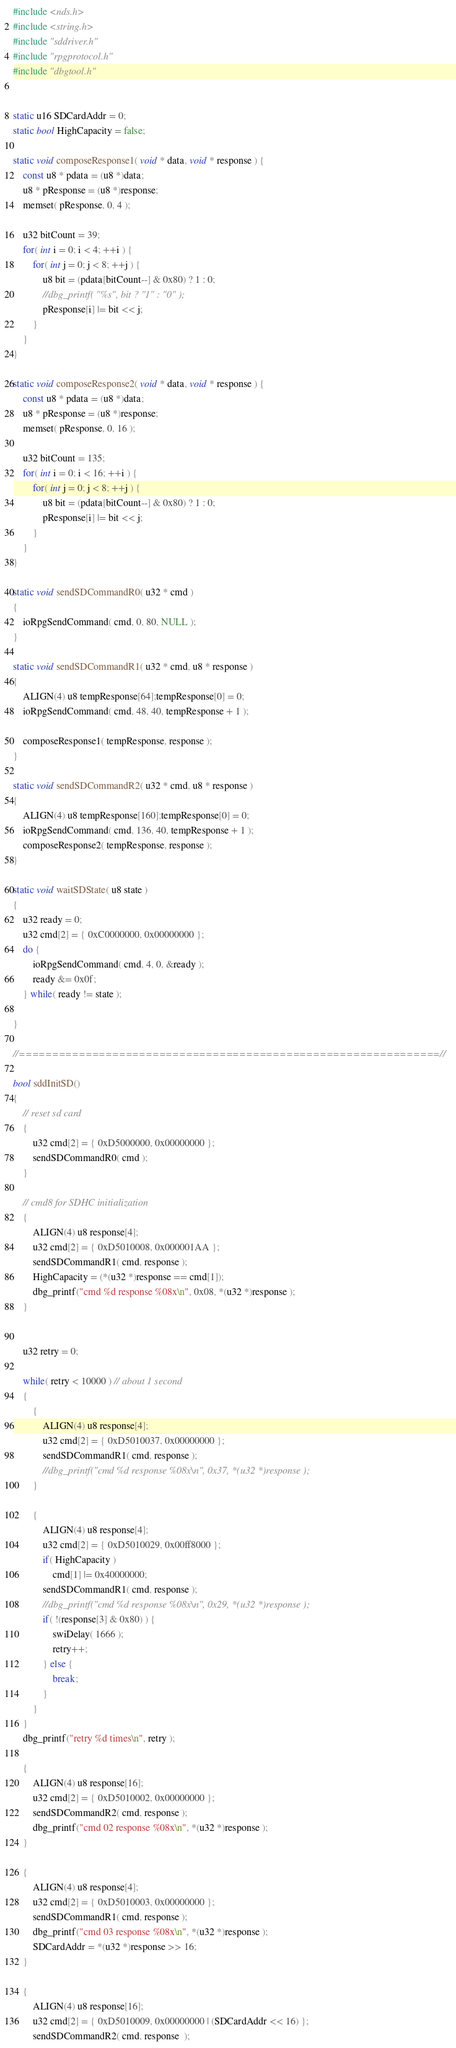Convert code to text. <code><loc_0><loc_0><loc_500><loc_500><_C++_>#include <nds.h>
#include <string.h>
#include "sddriver.h"
#include "rpgprotocol.h"
#include "dbgtool.h"


static u16 SDCardAddr = 0;
static bool HighCapacity = false;

static void composeResponse1( void * data, void * response ) {
	const u8 * pdata = (u8 *)data;
	u8 * pResponse = (u8 *)response;
	memset( pResponse, 0, 4 );

	u32 bitCount = 39;
	for( int i = 0; i < 4; ++i ) {
		for( int j = 0; j < 8; ++j ) {
			u8 bit = (pdata[bitCount--] & 0x80) ? 1 : 0;
			//dbg_printf( "%s", bit ? "1" : "0" );
			pResponse[i] |= bit << j;
		}
	}
}

static void composeResponse2( void * data, void * response ) {
	const u8 * pdata = (u8 *)data;
	u8 * pResponse = (u8 *)response;
	memset( pResponse, 0, 16 );

	u32 bitCount = 135;
	for( int i = 0; i < 16; ++i ) {
		for( int j = 0; j < 8; ++j ) {
			u8 bit = (pdata[bitCount--] & 0x80) ? 1 : 0;
			pResponse[i] |= bit << j;
		}
	}
}

static void sendSDCommandR0( u32 * cmd )
{
	ioRpgSendCommand( cmd, 0, 80, NULL );
}

static void sendSDCommandR1( u32 * cmd, u8 * response )
{
	ALIGN(4) u8 tempResponse[64];tempResponse[0] = 0;
	ioRpgSendCommand( cmd, 48, 40, tempResponse + 1 );

	composeResponse1( tempResponse, response );
}

static void sendSDCommandR2( u32 * cmd, u8 * response )
{
	ALIGN(4) u8 tempResponse[160];tempResponse[0] = 0;
	ioRpgSendCommand( cmd, 136, 40, tempResponse + 1 );
	composeResponse2( tempResponse, response );
}

static void waitSDState( u8 state )
{
	u32 ready = 0;
	u32 cmd[2] = { 0xC0000000, 0x00000000 };
	do {
		ioRpgSendCommand( cmd, 4, 0, &ready );
		ready &= 0x0f;
	} while( ready != state );

}

//===============================================================//

bool sddInitSD()
{
	// reset sd card
	{
		u32 cmd[2] = { 0xD5000000, 0x00000000 };
		sendSDCommandR0( cmd );
	}

	// cmd8 for SDHC initialization
	{
		ALIGN(4) u8 response[4];
		u32 cmd[2] = { 0xD5010008, 0x000001AA };
		sendSDCommandR1( cmd, response );
		HighCapacity = (*(u32 *)response == cmd[1]);
		dbg_printf("cmd %d response %08x\n", 0x08, *(u32 *)response );
	}


	u32 retry = 0;

	while( retry < 10000 ) // about 1 second
	{
		{
			ALIGN(4) u8 response[4];
			u32 cmd[2] = { 0xD5010037, 0x00000000 };
			sendSDCommandR1( cmd, response );
			//dbg_printf("cmd %d response %08x\n", 0x37, *(u32 *)response );
		}

		{
			ALIGN(4) u8 response[4];
			u32 cmd[2] = { 0xD5010029, 0x00ff8000 };
			if( HighCapacity )
				cmd[1] |= 0x40000000;
			sendSDCommandR1( cmd, response );
			//dbg_printf("cmd %d response %08x\n", 0x29, *(u32 *)response );
			if( !(response[3] & 0x80) ) {
				swiDelay( 1666 );
				retry++;
			} else {
				break;
			}
		}
	}
	dbg_printf("retry %d times\n", retry );

	{
		ALIGN(4) u8 response[16];
		u32 cmd[2] = { 0xD5010002, 0x00000000 };
		sendSDCommandR2( cmd, response );
		dbg_printf("cmd 02 response %08x\n", *(u32 *)response );
	}

	{
		ALIGN(4) u8 response[4];
		u32 cmd[2] = { 0xD5010003, 0x00000000 };
		sendSDCommandR1( cmd, response );
		dbg_printf("cmd 03 response %08x\n", *(u32 *)response );
		SDCardAddr = *(u32 *)response >> 16;
	}

	{
		ALIGN(4) u8 response[16];
		u32 cmd[2] = { 0xD5010009, 0x00000000 | (SDCardAddr << 16) };
		sendSDCommandR2( cmd, response  );</code> 